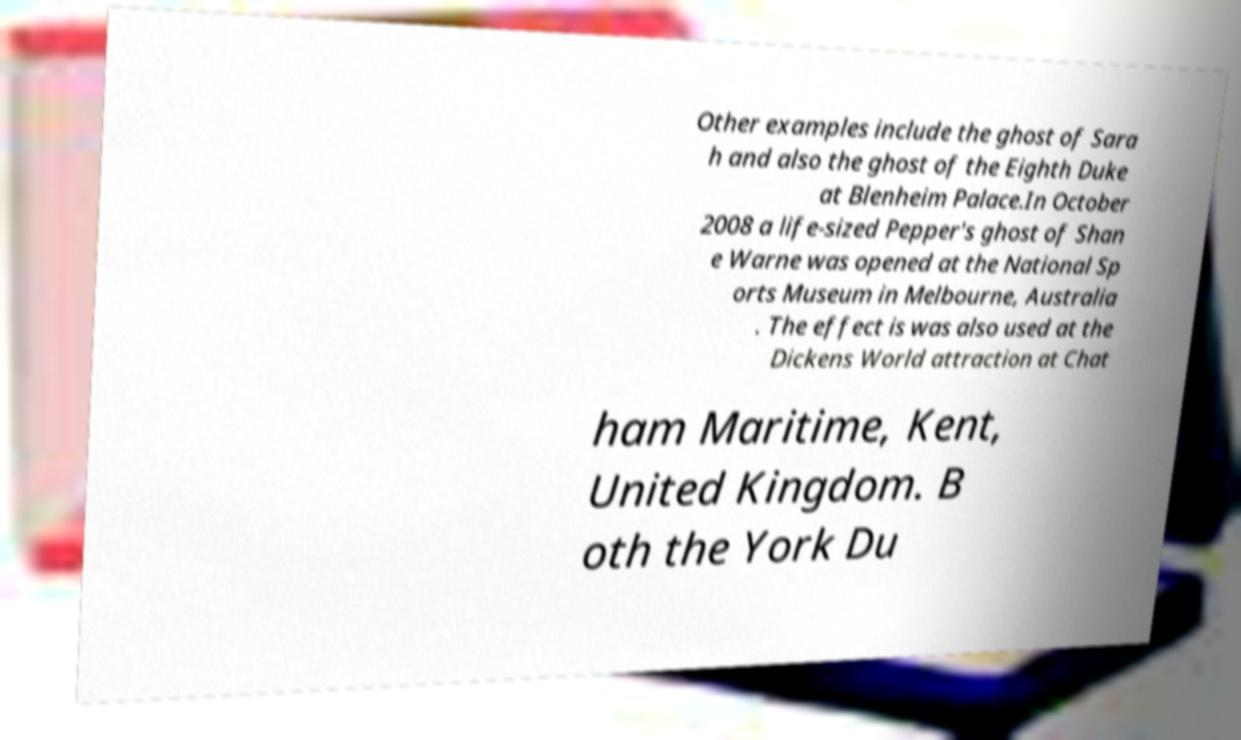Can you read and provide the text displayed in the image?This photo seems to have some interesting text. Can you extract and type it out for me? Other examples include the ghost of Sara h and also the ghost of the Eighth Duke at Blenheim Palace.In October 2008 a life-sized Pepper's ghost of Shan e Warne was opened at the National Sp orts Museum in Melbourne, Australia . The effect is was also used at the Dickens World attraction at Chat ham Maritime, Kent, United Kingdom. B oth the York Du 